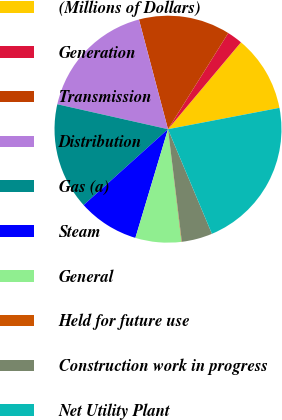Convert chart. <chart><loc_0><loc_0><loc_500><loc_500><pie_chart><fcel>(Millions of Dollars)<fcel>Generation<fcel>Transmission<fcel>Distribution<fcel>Gas (a)<fcel>Steam<fcel>General<fcel>Held for future use<fcel>Construction work in progress<fcel>Net Utility Plant<nl><fcel>10.87%<fcel>2.21%<fcel>13.03%<fcel>17.35%<fcel>15.19%<fcel>8.7%<fcel>6.54%<fcel>0.05%<fcel>4.38%<fcel>21.68%<nl></chart> 